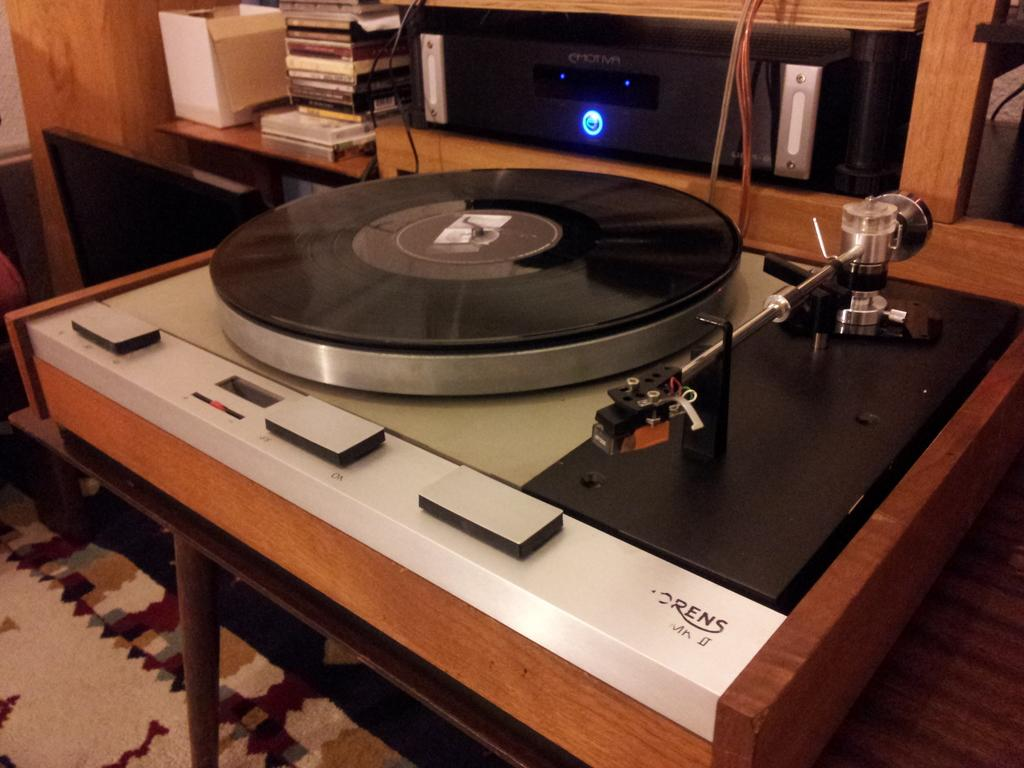What electronic device is present in the image? There is a CD player in the image. What color is the CD player? The CD player is black in color. What can be seen in the background of the image? There are books on a table in the background. What is the color of the table? The table is brown in color. What type of authority figure can be seen in the image? There is no authority figure present in the image; it only features a CD player, books, and a table. How many elbows are visible in the image? There are no elbows visible in the image, as it does not depict any people or body parts. 